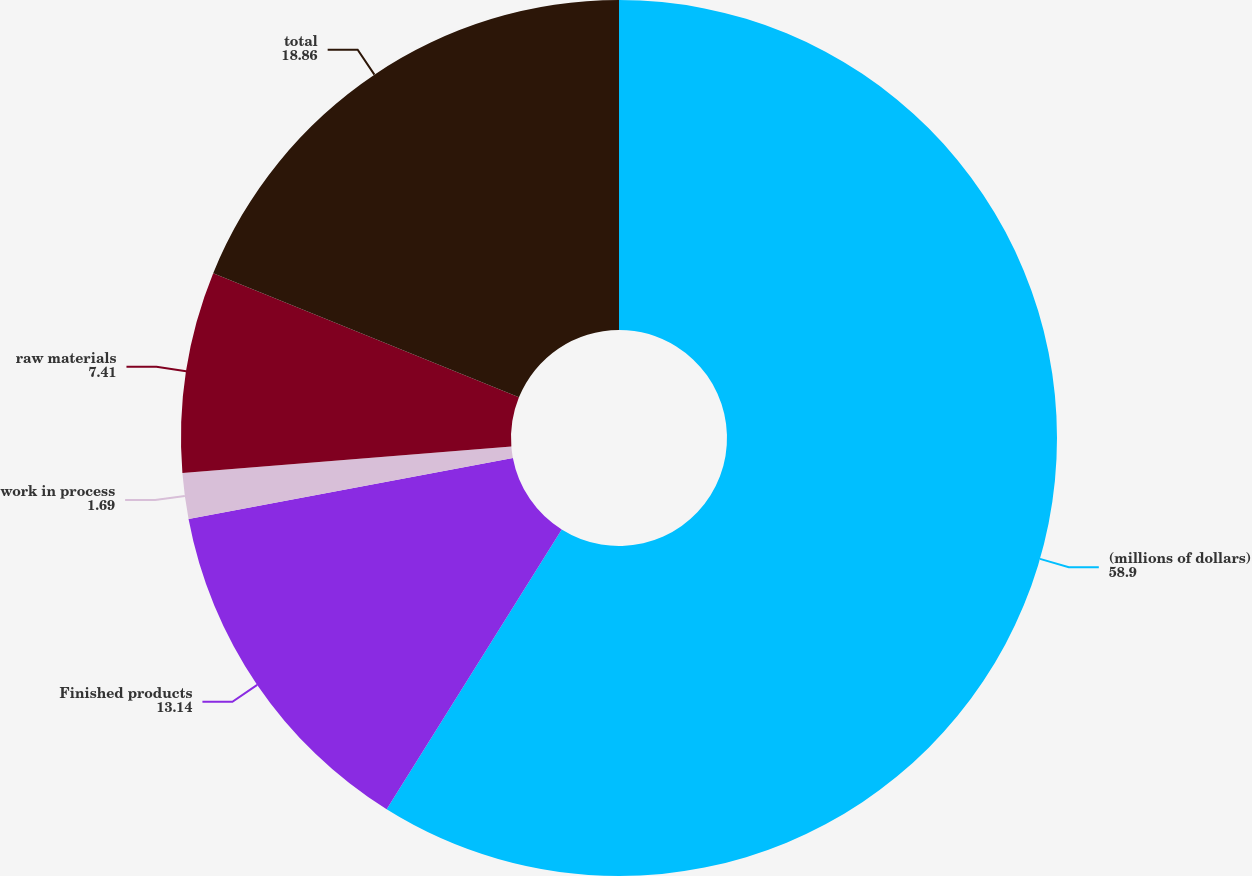Convert chart to OTSL. <chart><loc_0><loc_0><loc_500><loc_500><pie_chart><fcel>(millions of dollars)<fcel>Finished products<fcel>work in process<fcel>raw materials<fcel>total<nl><fcel>58.9%<fcel>13.14%<fcel>1.69%<fcel>7.41%<fcel>18.86%<nl></chart> 